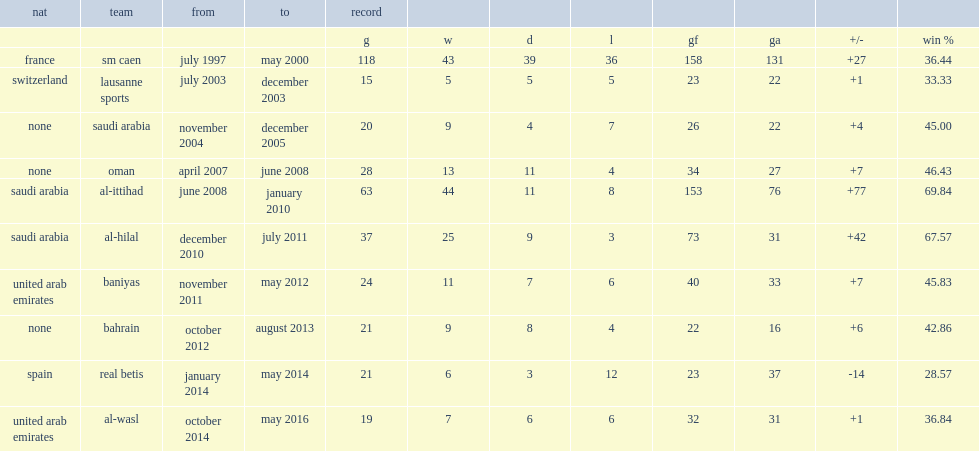Can you give me this table as a dict? {'header': ['nat', 'team', 'from', 'to', 'record', '', '', '', '', '', '', ''], 'rows': [['', '', '', '', 'g', 'w', 'd', 'l', 'gf', 'ga', '+/-', 'win %'], ['france', 'sm caen', 'july 1997', 'may 2000', '118', '43', '39', '36', '158', '131', '+27', '36.44'], ['switzerland', 'lausanne sports', 'july 2003', 'december 2003', '15', '5', '5', '5', '23', '22', '+1', '33.33'], ['none', 'saudi arabia', 'november 2004', 'december 2005', '20', '9', '4', '7', '26', '22', '+4', '45.00'], ['none', 'oman', 'april 2007', 'june 2008', '28', '13', '11', '4', '34', '27', '+7', '46.43'], ['saudi arabia', 'al-ittihad', 'june 2008', 'january 2010', '63', '44', '11', '8', '153', '76', '+77', '69.84'], ['saudi arabia', 'al-hilal', 'december 2010', 'july 2011', '37', '25', '9', '3', '73', '31', '+42', '67.57'], ['united arab emirates', 'baniyas', 'november 2011', 'may 2012', '24', '11', '7', '6', '40', '33', '+7', '45.83'], ['none', 'bahrain', 'october 2012', 'august 2013', '21', '9', '8', '4', '22', '16', '+6', '42.86'], ['spain', 'real betis', 'january 2014', 'may 2014', '21', '6', '3', '12', '23', '37', '-14', '28.57'], ['united arab emirates', 'al-wasl', 'october 2014', 'may 2016', '19', '7', '6', '6', '32', '31', '+1', '36.84']]} When did gabriel calderon move to al-ittihad? Al-ittihad. 